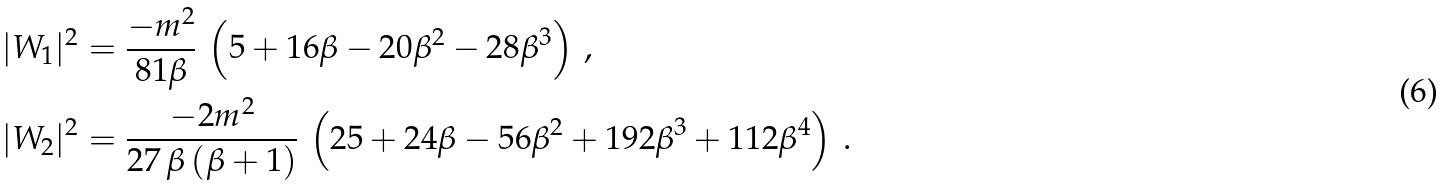<formula> <loc_0><loc_0><loc_500><loc_500>& | W _ { 1 } | ^ { 2 } = \frac { - m ^ { 2 } } { 8 1 \beta } \, \left ( 5 + 1 6 \beta - 2 0 \beta ^ { 2 } - 2 8 \beta ^ { 3 } \right ) \, , \\ & | W _ { 2 } | ^ { 2 } = \frac { - 2 m ^ { 2 } } { 2 7 \, \beta \, ( \beta + 1 ) } \, \left ( 2 5 + 2 4 \beta - 5 6 \beta ^ { 2 } + 1 9 2 \beta ^ { 3 } + 1 1 2 \beta ^ { 4 } \right ) \, .</formula> 